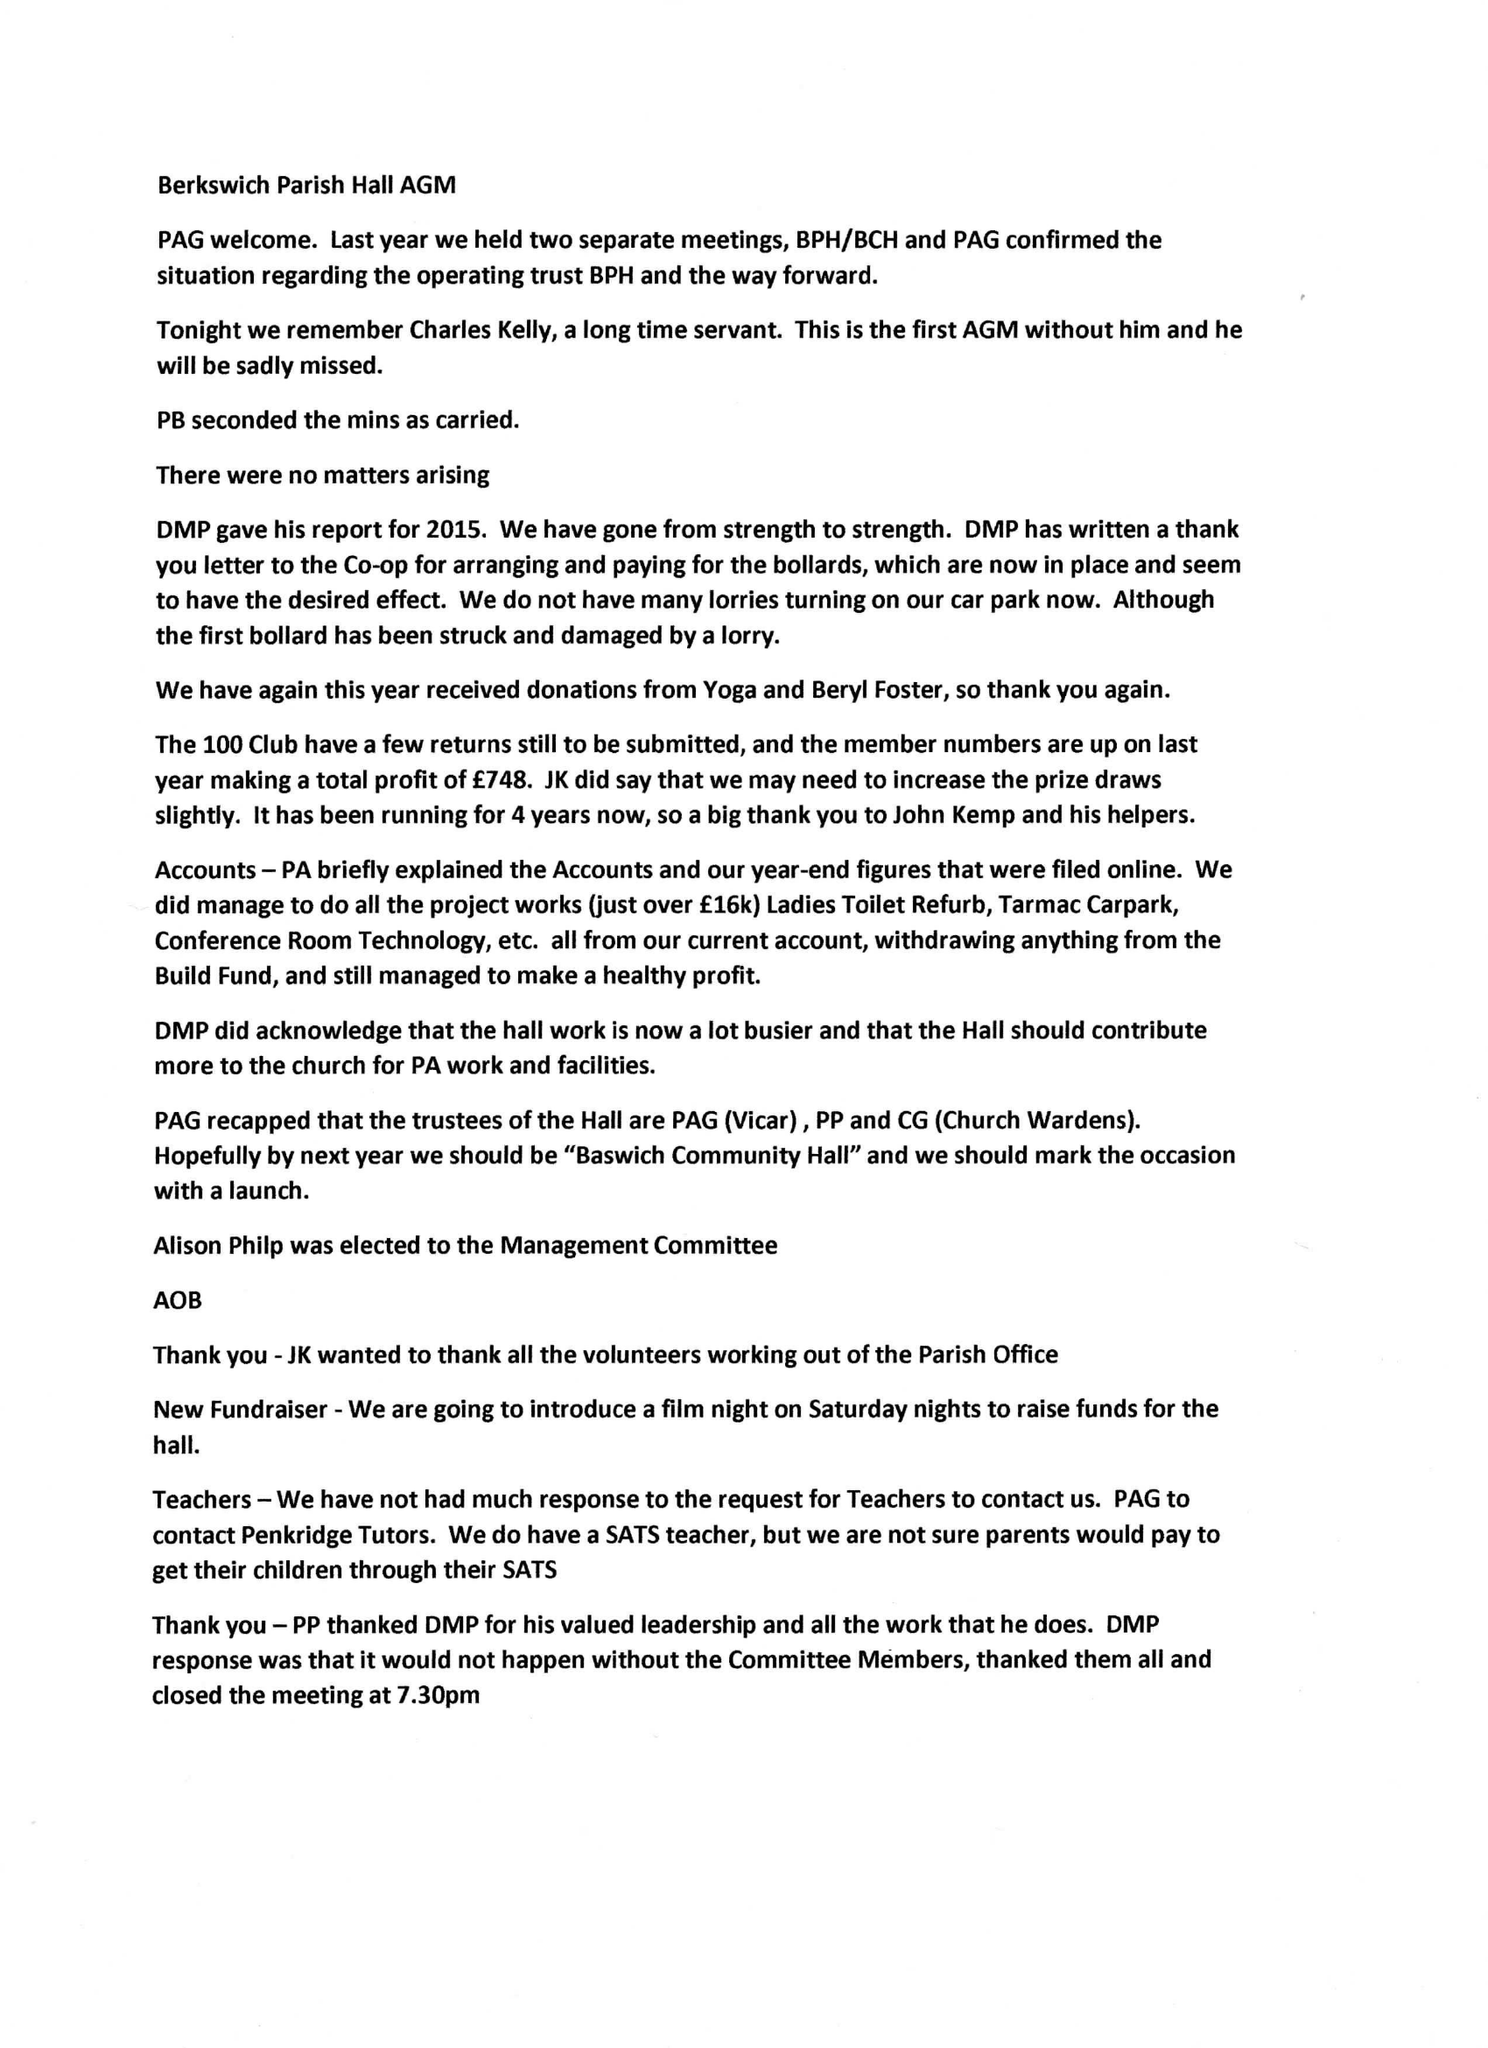What is the value for the charity_name?
Answer the question using a single word or phrase. Berkswich Parish Hall 